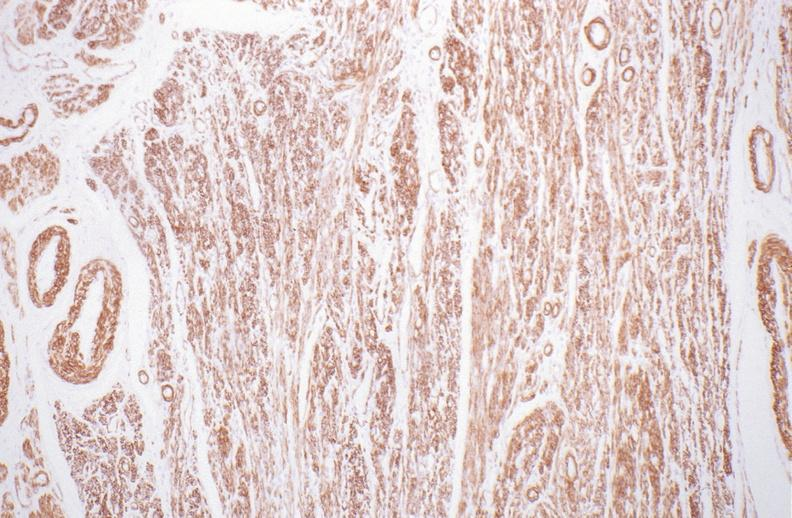does cervical carcinoma show normal uterus?
Answer the question using a single word or phrase. No 